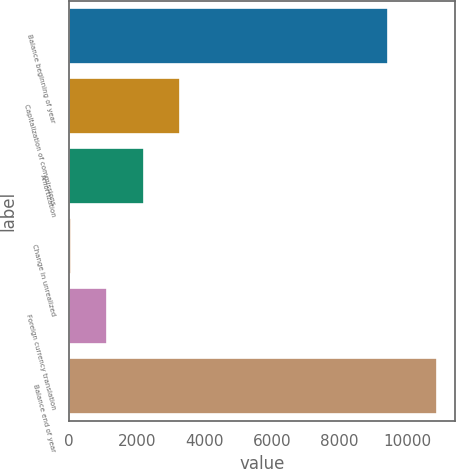Convert chart to OTSL. <chart><loc_0><loc_0><loc_500><loc_500><bar_chart><fcel>Balance beginning of year<fcel>Capitalization of commissions<fcel>Amortization<fcel>Change in unrealized<fcel>Foreign currency translation<fcel>Balance end of year<nl><fcel>9438<fcel>3290.4<fcel>2208.6<fcel>45<fcel>1126.8<fcel>10863<nl></chart> 